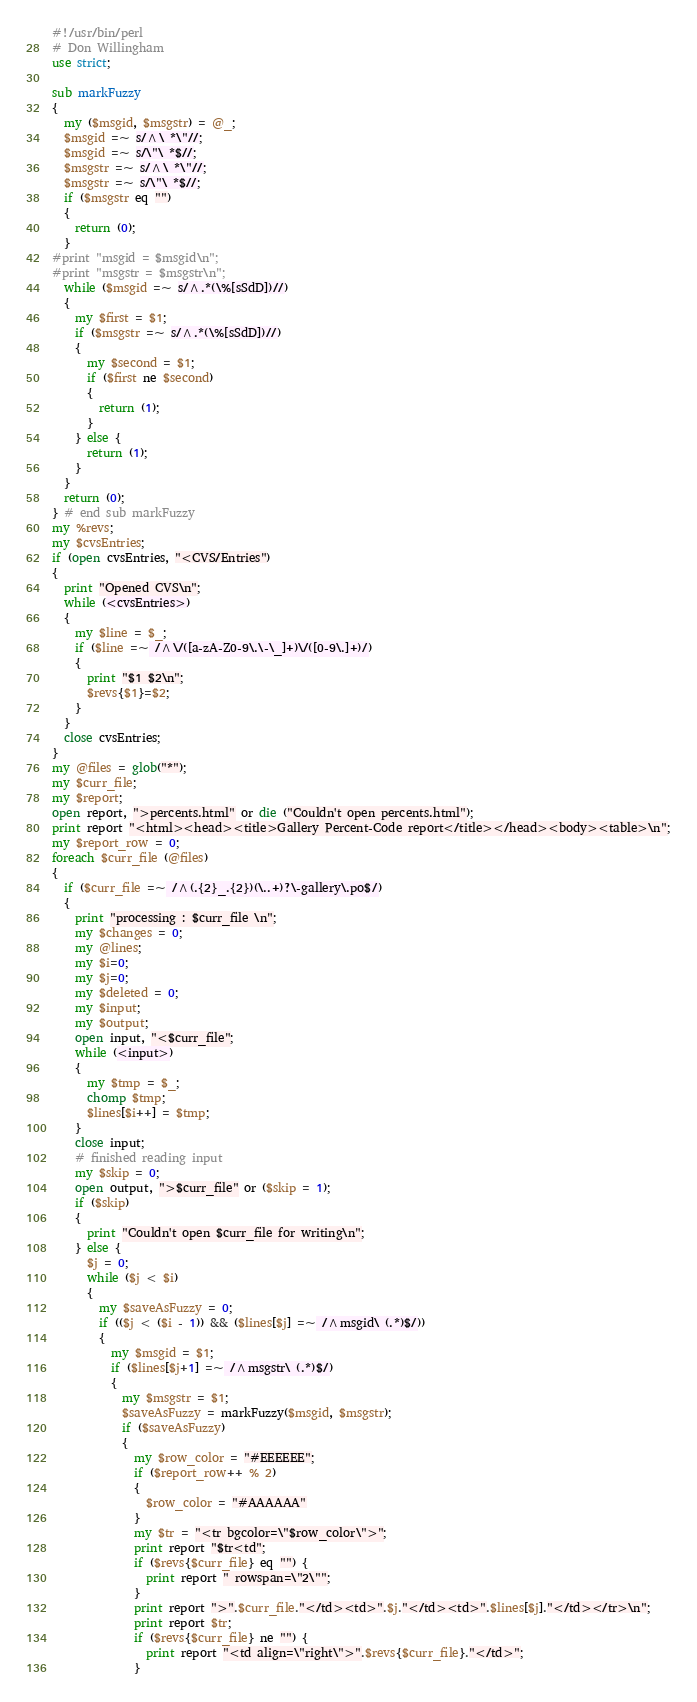<code> <loc_0><loc_0><loc_500><loc_500><_Perl_>#!/usr/bin/perl
# Don Willingham
use strict;

sub markFuzzy
{
  my ($msgid, $msgstr) = @_;
  $msgid =~ s/^\ *\"//;
  $msgid =~ s/\"\ *$//;
  $msgstr =~ s/^\ *\"//;
  $msgstr =~ s/\"\ *$//;
  if ($msgstr eq "")
  {
    return (0);
  }
#print "msgid = $msgid\n";
#print "msgstr = $msgstr\n";
  while ($msgid =~ s/^.*(\%[sSdD])//)
  {
    my $first = $1;
    if ($msgstr =~ s/^.*(\%[sSdD])//)
    {
      my $second = $1;
      if ($first ne $second)
      {
        return (1);
      }
    } else {
      return (1);
    }
  }
  return (0);
} # end sub markFuzzy
my %revs;
my $cvsEntries;
if (open cvsEntries, "<CVS/Entries")
{
  print "Opened CVS\n";
  while (<cvsEntries>)
  {
    my $line = $_;
    if ($line =~ /^\/([a-zA-Z0-9\.\-\_]+)\/([0-9\.]+)/)
    {
      print "$1 $2\n";
      $revs{$1}=$2;
    }
  }
  close cvsEntries;
}
my @files = glob("*");
my $curr_file;
my $report;
open report, ">percents.html" or die ("Couldn't open percents.html");
print report "<html><head><title>Gallery Percent-Code report</title></head><body><table>\n";
my $report_row = 0;
foreach $curr_file (@files)
{
  if ($curr_file =~ /^(.{2}_.{2})(\..+)?\-gallery\.po$/)
  {
    print "processing : $curr_file \n";
    my $changes = 0;
    my @lines;
    my $i=0;
    my $j=0;
    my $deleted = 0;
    my $input;
    my $output;
    open input, "<$curr_file";
    while (<input>)
    {
      my $tmp = $_;
      chomp $tmp;
      $lines[$i++] = $tmp;
    }
    close input;
    # finished reading input
    my $skip = 0;
    open output, ">$curr_file" or ($skip = 1);
    if ($skip)
    {
      print "Couldn't open $curr_file for writing\n";
    } else {
      $j = 0;
      while ($j < $i)
      {
        my $saveAsFuzzy = 0;
        if (($j < ($i - 1)) && ($lines[$j] =~ /^msgid\ (.*)$/))
        {
          my $msgid = $1;
          if ($lines[$j+1] =~ /^msgstr\ (.*)$/)
          {
            my $msgstr = $1;
            $saveAsFuzzy = markFuzzy($msgid, $msgstr);
            if ($saveAsFuzzy)
            {
              my $row_color = "#EEEEEE";
              if ($report_row++ % 2)
              {
                $row_color = "#AAAAAA"
              }
              my $tr = "<tr bgcolor=\"$row_color\">";
              print report "$tr<td";
              if ($revs{$curr_file} eq "") {
                print report " rowspan=\"2\"";
              }
              print report ">".$curr_file."</td><td>".$j."</td><td>".$lines[$j]."</td></tr>\n";
              print report $tr;
              if ($revs{$curr_file} ne "") {
                print report "<td align=\"right\">".$revs{$curr_file}."</td>";
              }</code> 